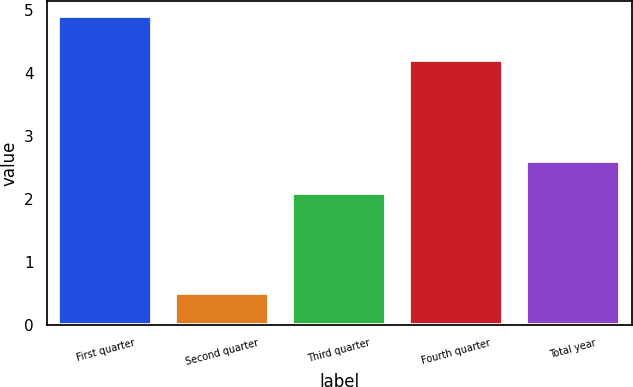<chart> <loc_0><loc_0><loc_500><loc_500><bar_chart><fcel>First quarter<fcel>Second quarter<fcel>Third quarter<fcel>Fourth quarter<fcel>Total year<nl><fcel>4.9<fcel>0.5<fcel>2.1<fcel>4.2<fcel>2.6<nl></chart> 